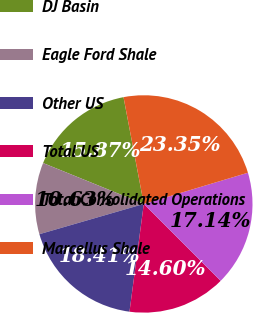Convert chart. <chart><loc_0><loc_0><loc_500><loc_500><pie_chart><fcel>DJ Basin<fcel>Eagle Ford Shale<fcel>Other US<fcel>Total US<fcel>Total Consolidated Operations<fcel>Marcellus Shale<nl><fcel>15.87%<fcel>10.63%<fcel>18.41%<fcel>14.6%<fcel>17.14%<fcel>23.35%<nl></chart> 